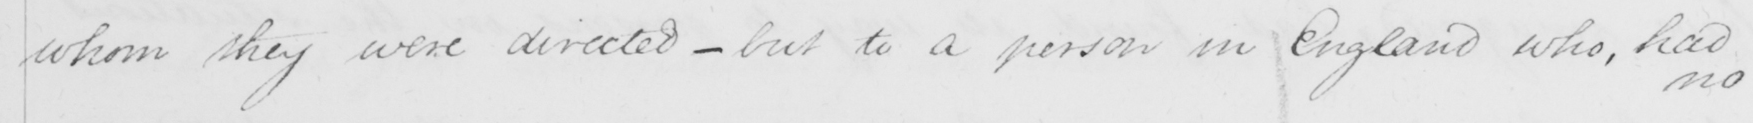Can you tell me what this handwritten text says? whom they were directed  _  but to a person in England who , had 